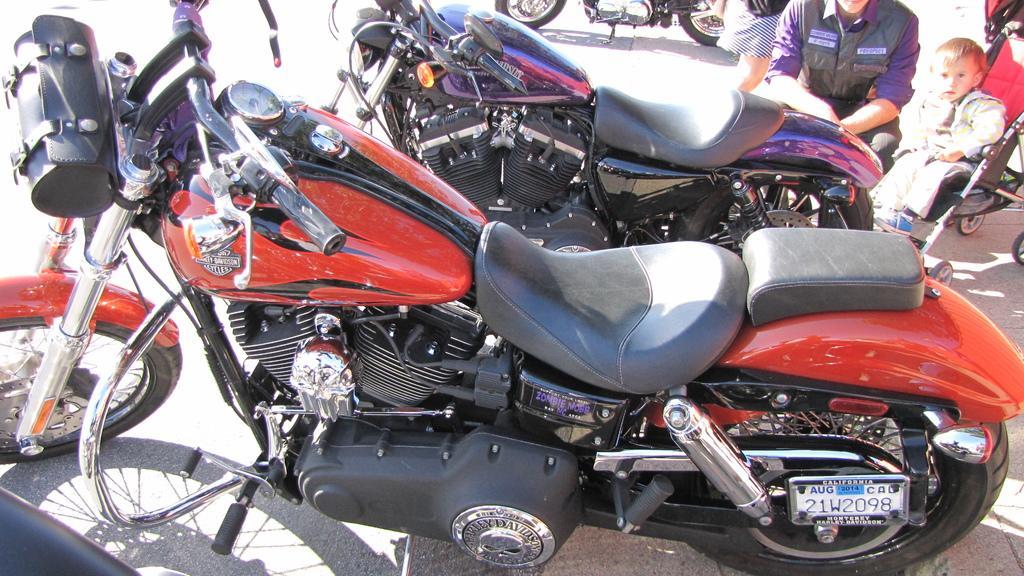Please provide a concise description of this image. In this image there are few bikes. On the top right there are few people. One kid is on the stroller. 